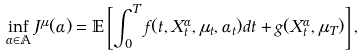Convert formula to latex. <formula><loc_0><loc_0><loc_500><loc_500>\inf _ { \alpha \in \mathbb { A } } J ^ { \mu } ( \alpha ) = \mathbb { E } \left [ \int _ { 0 } ^ { T } f ( t , X ^ { \alpha } _ { t } , \mu _ { t } , \alpha _ { t } ) d t + g ( X ^ { \alpha } _ { t } , \mu _ { T } ) \right ] ,</formula> 